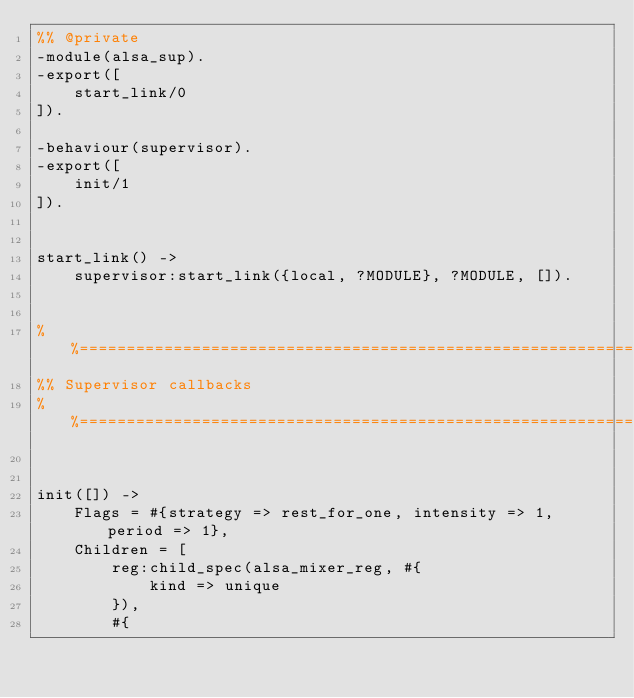<code> <loc_0><loc_0><loc_500><loc_500><_Erlang_>%% @private
-module(alsa_sup).
-export([
    start_link/0
]).

-behaviour(supervisor).
-export([
    init/1
]).


start_link() ->
    supervisor:start_link({local, ?MODULE}, ?MODULE, []).


%%====================================================================
%% Supervisor callbacks
%%====================================================================


init([]) ->
    Flags = #{strategy => rest_for_one, intensity => 1, period => 1},
    Children = [
        reg:child_spec(alsa_mixer_reg, #{
            kind => unique
        }),
        #{</code> 